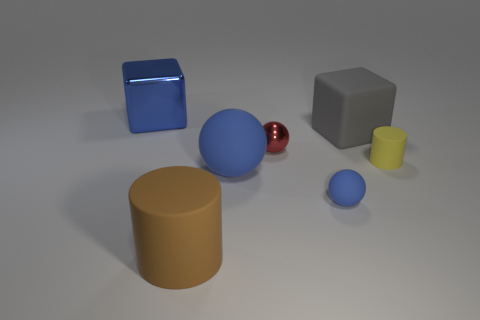Add 1 shiny objects. How many objects exist? 8 Subtract all cylinders. How many objects are left? 5 Subtract all small green metal balls. Subtract all red spheres. How many objects are left? 6 Add 5 gray matte objects. How many gray matte objects are left? 6 Add 4 blue spheres. How many blue spheres exist? 6 Subtract 1 blue blocks. How many objects are left? 6 